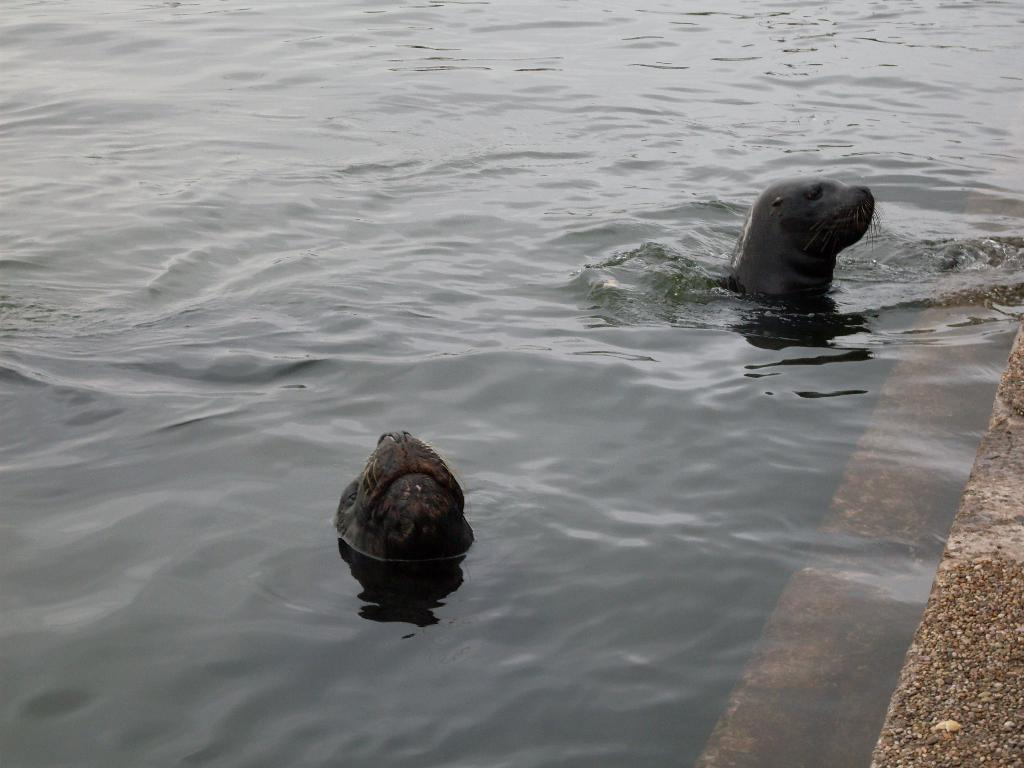What is the primary element in the image? There is water in the image. What animals can be seen in the water? There are two seals in the water. Where are the steps located in the image? The steps are in the bottom right corner of the image. What type of property can be seen in the image? There is no property visible in the image; it primarily features water with seals and steps. Can you see a basketball being played in the image? There is no basketball or indication of a game being played in the image. 